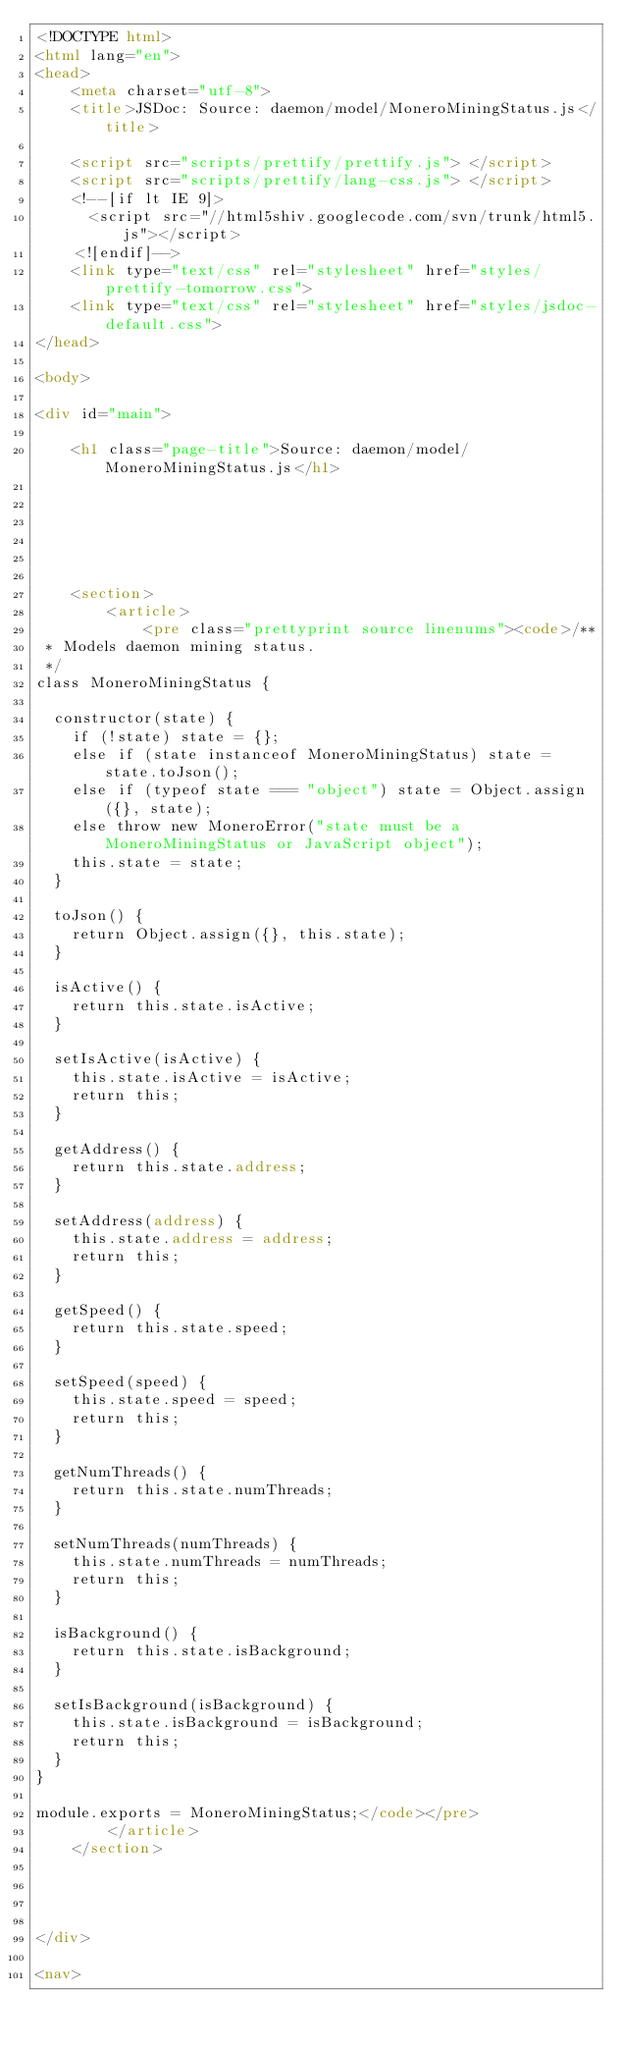Convert code to text. <code><loc_0><loc_0><loc_500><loc_500><_HTML_><!DOCTYPE html>
<html lang="en">
<head>
    <meta charset="utf-8">
    <title>JSDoc: Source: daemon/model/MoneroMiningStatus.js</title>

    <script src="scripts/prettify/prettify.js"> </script>
    <script src="scripts/prettify/lang-css.js"> </script>
    <!--[if lt IE 9]>
      <script src="//html5shiv.googlecode.com/svn/trunk/html5.js"></script>
    <![endif]-->
    <link type="text/css" rel="stylesheet" href="styles/prettify-tomorrow.css">
    <link type="text/css" rel="stylesheet" href="styles/jsdoc-default.css">
</head>

<body>

<div id="main">

    <h1 class="page-title">Source: daemon/model/MoneroMiningStatus.js</h1>

    



    
    <section>
        <article>
            <pre class="prettyprint source linenums"><code>/**
 * Models daemon mining status.
 */
class MoneroMiningStatus {
  
  constructor(state) {
    if (!state) state = {};
    else if (state instanceof MoneroMiningStatus) state = state.toJson();
    else if (typeof state === "object") state = Object.assign({}, state);
    else throw new MoneroError("state must be a MoneroMiningStatus or JavaScript object");
    this.state = state;
  }
  
  toJson() {
    return Object.assign({}, this.state);
  }
  
  isActive() {
    return this.state.isActive;
  }
  
  setIsActive(isActive) {
    this.state.isActive = isActive;
    return this;
  }
  
  getAddress() {
    return this.state.address;
  }
  
  setAddress(address) {
    this.state.address = address;
    return this;
  }
  
  getSpeed() {
    return this.state.speed;
  }
  
  setSpeed(speed) {
    this.state.speed = speed;
    return this;
  }
  
  getNumThreads() {
    return this.state.numThreads;
  }
  
  setNumThreads(numThreads) {
    this.state.numThreads = numThreads;
    return this;
  }
  
  isBackground() {
    return this.state.isBackground;
  }
  
  setIsBackground(isBackground) {
    this.state.isBackground = isBackground;
    return this;
  }
}

module.exports = MoneroMiningStatus;</code></pre>
        </article>
    </section>




</div>

<nav></code> 